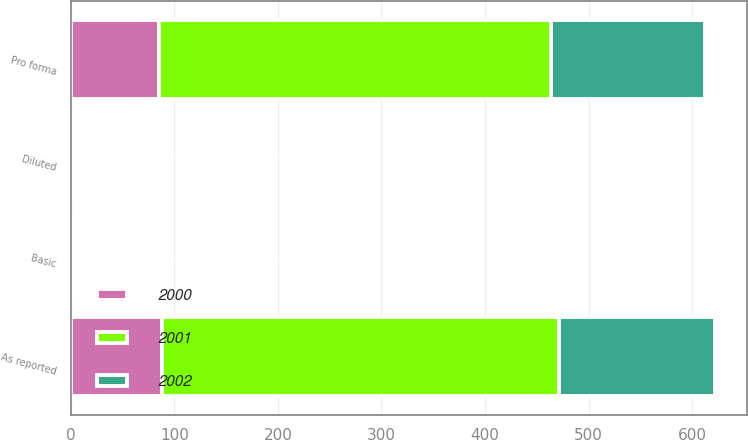<chart> <loc_0><loc_0><loc_500><loc_500><stacked_bar_chart><ecel><fcel>As reported<fcel>Pro forma<fcel>Basic<fcel>Diluted<nl><fcel>2001<fcel>383<fcel>379<fcel>1.1<fcel>1.08<nl><fcel>2000<fcel>88<fcel>85<fcel>0.4<fcel>0.4<nl><fcel>2002<fcel>151<fcel>148<fcel>0.67<fcel>0.67<nl></chart> 